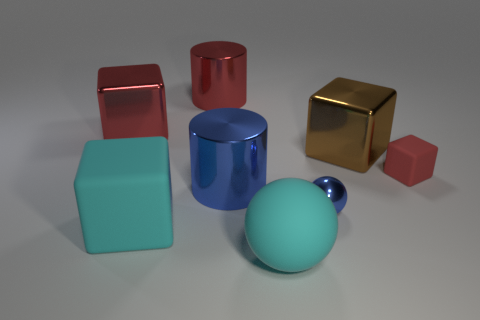What is the big red object that is in front of the big metallic cylinder behind the large brown shiny cube made of?
Keep it short and to the point. Metal. Is the number of big cylinders behind the tiny red matte object greater than the number of blue rubber objects?
Your response must be concise. Yes. How many other objects are there of the same size as the cyan cube?
Provide a succinct answer. 5. Is the color of the big rubber ball the same as the big matte cube?
Provide a succinct answer. Yes. There is a metal cylinder that is right of the large red object that is on the right side of the red cube that is on the left side of the cyan block; what is its color?
Make the answer very short. Blue. How many small matte things are behind the big matte object on the left side of the big metal cylinder that is behind the big brown metallic thing?
Keep it short and to the point. 1. Is there anything else that is the same color as the matte ball?
Give a very brief answer. Yes. Do the shiny block that is on the left side of the matte sphere and the tiny rubber object have the same size?
Give a very brief answer. No. How many big metallic cylinders are behind the rubber object behind the blue cylinder?
Offer a terse response. 1. There is a red object that is behind the red block that is behind the tiny rubber cube; is there a blue sphere that is behind it?
Make the answer very short. No. 